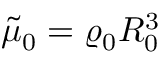Convert formula to latex. <formula><loc_0><loc_0><loc_500><loc_500>\tilde { \mu } _ { 0 } = \varrho _ { 0 } R _ { 0 } ^ { 3 }</formula> 